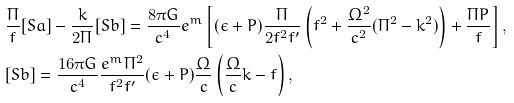Convert formula to latex. <formula><loc_0><loc_0><loc_500><loc_500>& \frac { \Pi } { f } [ S a ] - \frac { k } { 2 \Pi } [ S b ] = \frac { 8 \pi G } { c ^ { 4 } } e ^ { m } \left [ ( \epsilon + P ) \frac { \Pi } { 2 f ^ { 2 } f ^ { \prime } } \left ( f ^ { 2 } + \frac { \Omega ^ { 2 } } { c ^ { 2 } } ( \Pi ^ { 2 } - k ^ { 2 } ) \right ) + \frac { \Pi P } { f } \right ] , \\ & [ S b ] = \frac { 1 6 \pi G } { c ^ { 4 } } \frac { e ^ { m } \Pi ^ { 2 } } { f ^ { 2 } f ^ { \prime } } ( \epsilon + P ) \frac { \Omega } { c } \left ( \frac { \Omega } { c } k - f \right ) ,</formula> 